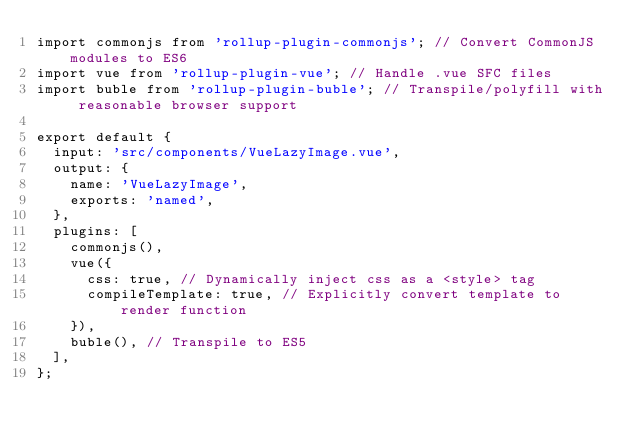<code> <loc_0><loc_0><loc_500><loc_500><_JavaScript_>import commonjs from 'rollup-plugin-commonjs'; // Convert CommonJS modules to ES6
import vue from 'rollup-plugin-vue'; // Handle .vue SFC files
import buble from 'rollup-plugin-buble'; // Transpile/polyfill with reasonable browser support

export default {
  input: 'src/components/VueLazyImage.vue',
  output: {
    name: 'VueLazyImage',
    exports: 'named',
  },
  plugins: [
    commonjs(),
    vue({
      css: true, // Dynamically inject css as a <style> tag
      compileTemplate: true, // Explicitly convert template to render function
    }),
    buble(), // Transpile to ES5
  ],
};
</code> 